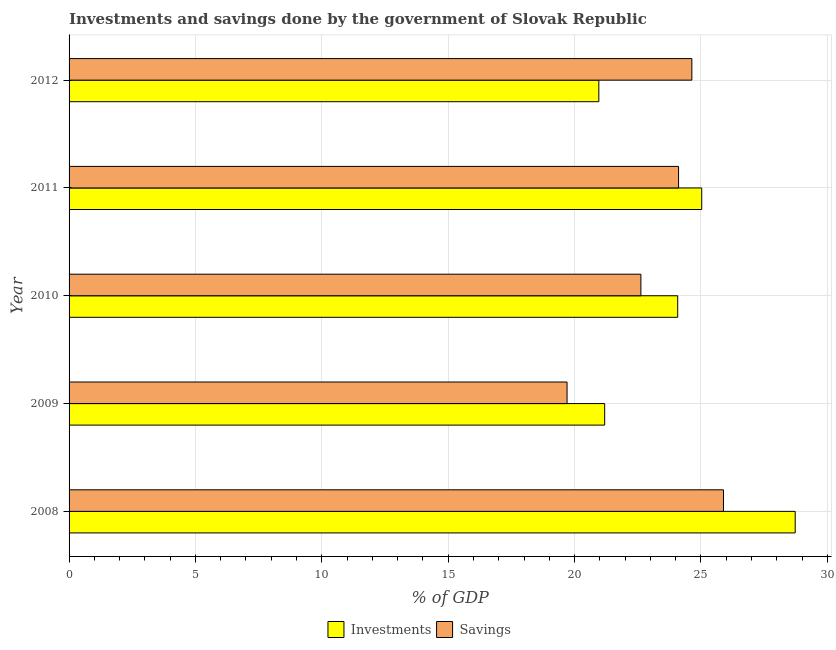Are the number of bars per tick equal to the number of legend labels?
Your answer should be very brief. Yes. How many bars are there on the 3rd tick from the top?
Your response must be concise. 2. How many bars are there on the 2nd tick from the bottom?
Ensure brevity in your answer.  2. In how many cases, is the number of bars for a given year not equal to the number of legend labels?
Give a very brief answer. 0. What is the investments of government in 2012?
Make the answer very short. 20.96. Across all years, what is the maximum investments of government?
Your answer should be compact. 28.73. Across all years, what is the minimum investments of government?
Give a very brief answer. 20.96. What is the total investments of government in the graph?
Offer a very short reply. 119.99. What is the difference between the savings of government in 2008 and that in 2011?
Your answer should be compact. 1.78. What is the difference between the investments of government in 2009 and the savings of government in 2008?
Keep it short and to the point. -4.7. What is the average investments of government per year?
Make the answer very short. 24. In the year 2011, what is the difference between the savings of government and investments of government?
Your response must be concise. -0.92. Is the difference between the investments of government in 2009 and 2012 greater than the difference between the savings of government in 2009 and 2012?
Make the answer very short. Yes. What is the difference between the highest and the second highest investments of government?
Your response must be concise. 3.7. What is the difference between the highest and the lowest savings of government?
Give a very brief answer. 6.19. In how many years, is the investments of government greater than the average investments of government taken over all years?
Offer a very short reply. 3. What does the 1st bar from the top in 2009 represents?
Provide a succinct answer. Savings. What does the 2nd bar from the bottom in 2012 represents?
Your response must be concise. Savings. How many years are there in the graph?
Offer a terse response. 5. Where does the legend appear in the graph?
Make the answer very short. Bottom center. How many legend labels are there?
Your answer should be very brief. 2. What is the title of the graph?
Make the answer very short. Investments and savings done by the government of Slovak Republic. Does "Male" appear as one of the legend labels in the graph?
Provide a succinct answer. No. What is the label or title of the X-axis?
Provide a short and direct response. % of GDP. What is the label or title of the Y-axis?
Ensure brevity in your answer.  Year. What is the % of GDP of Investments in 2008?
Offer a very short reply. 28.73. What is the % of GDP in Savings in 2008?
Your answer should be very brief. 25.89. What is the % of GDP of Investments in 2009?
Your answer should be very brief. 21.19. What is the % of GDP in Savings in 2009?
Provide a succinct answer. 19.7. What is the % of GDP of Investments in 2010?
Your response must be concise. 24.08. What is the % of GDP of Savings in 2010?
Provide a short and direct response. 22.62. What is the % of GDP of Investments in 2011?
Your answer should be compact. 25.03. What is the % of GDP of Savings in 2011?
Provide a short and direct response. 24.12. What is the % of GDP in Investments in 2012?
Offer a very short reply. 20.96. What is the % of GDP of Savings in 2012?
Your answer should be compact. 24.64. Across all years, what is the maximum % of GDP in Investments?
Offer a terse response. 28.73. Across all years, what is the maximum % of GDP in Savings?
Offer a terse response. 25.89. Across all years, what is the minimum % of GDP in Investments?
Provide a short and direct response. 20.96. Across all years, what is the minimum % of GDP in Savings?
Your answer should be compact. 19.7. What is the total % of GDP in Investments in the graph?
Your answer should be compact. 119.99. What is the total % of GDP of Savings in the graph?
Your answer should be very brief. 116.98. What is the difference between the % of GDP in Investments in 2008 and that in 2009?
Give a very brief answer. 7.54. What is the difference between the % of GDP of Savings in 2008 and that in 2009?
Make the answer very short. 6.19. What is the difference between the % of GDP in Investments in 2008 and that in 2010?
Offer a terse response. 4.65. What is the difference between the % of GDP of Savings in 2008 and that in 2010?
Give a very brief answer. 3.27. What is the difference between the % of GDP of Investments in 2008 and that in 2011?
Your answer should be compact. 3.7. What is the difference between the % of GDP of Savings in 2008 and that in 2011?
Ensure brevity in your answer.  1.78. What is the difference between the % of GDP in Investments in 2008 and that in 2012?
Your answer should be very brief. 7.77. What is the difference between the % of GDP of Savings in 2008 and that in 2012?
Ensure brevity in your answer.  1.25. What is the difference between the % of GDP in Investments in 2009 and that in 2010?
Your response must be concise. -2.89. What is the difference between the % of GDP of Savings in 2009 and that in 2010?
Make the answer very short. -2.92. What is the difference between the % of GDP of Investments in 2009 and that in 2011?
Offer a very short reply. -3.84. What is the difference between the % of GDP of Savings in 2009 and that in 2011?
Offer a very short reply. -4.41. What is the difference between the % of GDP in Investments in 2009 and that in 2012?
Your answer should be compact. 0.23. What is the difference between the % of GDP of Savings in 2009 and that in 2012?
Provide a succinct answer. -4.94. What is the difference between the % of GDP of Investments in 2010 and that in 2011?
Your answer should be very brief. -0.95. What is the difference between the % of GDP of Savings in 2010 and that in 2011?
Provide a succinct answer. -1.49. What is the difference between the % of GDP of Investments in 2010 and that in 2012?
Your answer should be very brief. 3.12. What is the difference between the % of GDP of Savings in 2010 and that in 2012?
Offer a very short reply. -2.02. What is the difference between the % of GDP in Investments in 2011 and that in 2012?
Your response must be concise. 4.07. What is the difference between the % of GDP in Savings in 2011 and that in 2012?
Offer a very short reply. -0.53. What is the difference between the % of GDP in Investments in 2008 and the % of GDP in Savings in 2009?
Give a very brief answer. 9.03. What is the difference between the % of GDP of Investments in 2008 and the % of GDP of Savings in 2010?
Your response must be concise. 6.1. What is the difference between the % of GDP of Investments in 2008 and the % of GDP of Savings in 2011?
Provide a succinct answer. 4.61. What is the difference between the % of GDP of Investments in 2008 and the % of GDP of Savings in 2012?
Your response must be concise. 4.09. What is the difference between the % of GDP of Investments in 2009 and the % of GDP of Savings in 2010?
Provide a short and direct response. -1.43. What is the difference between the % of GDP of Investments in 2009 and the % of GDP of Savings in 2011?
Offer a very short reply. -2.92. What is the difference between the % of GDP of Investments in 2009 and the % of GDP of Savings in 2012?
Offer a very short reply. -3.45. What is the difference between the % of GDP of Investments in 2010 and the % of GDP of Savings in 2011?
Your response must be concise. -0.03. What is the difference between the % of GDP of Investments in 2010 and the % of GDP of Savings in 2012?
Offer a very short reply. -0.56. What is the difference between the % of GDP of Investments in 2011 and the % of GDP of Savings in 2012?
Provide a short and direct response. 0.39. What is the average % of GDP in Investments per year?
Your answer should be compact. 24. What is the average % of GDP of Savings per year?
Make the answer very short. 23.4. In the year 2008, what is the difference between the % of GDP in Investments and % of GDP in Savings?
Offer a very short reply. 2.84. In the year 2009, what is the difference between the % of GDP of Investments and % of GDP of Savings?
Provide a succinct answer. 1.49. In the year 2010, what is the difference between the % of GDP in Investments and % of GDP in Savings?
Your answer should be very brief. 1.46. In the year 2011, what is the difference between the % of GDP of Investments and % of GDP of Savings?
Give a very brief answer. 0.92. In the year 2012, what is the difference between the % of GDP of Investments and % of GDP of Savings?
Offer a terse response. -3.68. What is the ratio of the % of GDP of Investments in 2008 to that in 2009?
Your answer should be compact. 1.36. What is the ratio of the % of GDP in Savings in 2008 to that in 2009?
Offer a terse response. 1.31. What is the ratio of the % of GDP in Investments in 2008 to that in 2010?
Your answer should be very brief. 1.19. What is the ratio of the % of GDP in Savings in 2008 to that in 2010?
Provide a short and direct response. 1.14. What is the ratio of the % of GDP of Investments in 2008 to that in 2011?
Provide a succinct answer. 1.15. What is the ratio of the % of GDP in Savings in 2008 to that in 2011?
Ensure brevity in your answer.  1.07. What is the ratio of the % of GDP in Investments in 2008 to that in 2012?
Keep it short and to the point. 1.37. What is the ratio of the % of GDP in Savings in 2008 to that in 2012?
Offer a terse response. 1.05. What is the ratio of the % of GDP of Investments in 2009 to that in 2010?
Offer a terse response. 0.88. What is the ratio of the % of GDP of Savings in 2009 to that in 2010?
Your response must be concise. 0.87. What is the ratio of the % of GDP in Investments in 2009 to that in 2011?
Offer a terse response. 0.85. What is the ratio of the % of GDP in Savings in 2009 to that in 2011?
Your answer should be compact. 0.82. What is the ratio of the % of GDP of Savings in 2009 to that in 2012?
Offer a terse response. 0.8. What is the ratio of the % of GDP of Investments in 2010 to that in 2011?
Offer a very short reply. 0.96. What is the ratio of the % of GDP of Savings in 2010 to that in 2011?
Give a very brief answer. 0.94. What is the ratio of the % of GDP of Investments in 2010 to that in 2012?
Provide a short and direct response. 1.15. What is the ratio of the % of GDP in Savings in 2010 to that in 2012?
Provide a short and direct response. 0.92. What is the ratio of the % of GDP of Investments in 2011 to that in 2012?
Ensure brevity in your answer.  1.19. What is the ratio of the % of GDP in Savings in 2011 to that in 2012?
Offer a very short reply. 0.98. What is the difference between the highest and the second highest % of GDP in Investments?
Provide a short and direct response. 3.7. What is the difference between the highest and the second highest % of GDP of Savings?
Offer a terse response. 1.25. What is the difference between the highest and the lowest % of GDP of Investments?
Your answer should be very brief. 7.77. What is the difference between the highest and the lowest % of GDP of Savings?
Provide a short and direct response. 6.19. 